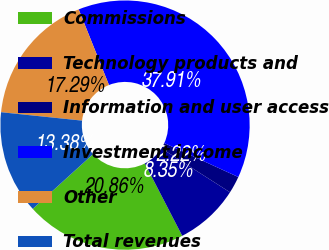Convert chart to OTSL. <chart><loc_0><loc_0><loc_500><loc_500><pie_chart><fcel>Commissions<fcel>Technology products and<fcel>Information and user access<fcel>Investment income<fcel>Other<fcel>Total revenues<nl><fcel>20.86%<fcel>8.35%<fcel>2.22%<fcel>37.91%<fcel>17.29%<fcel>13.38%<nl></chart> 